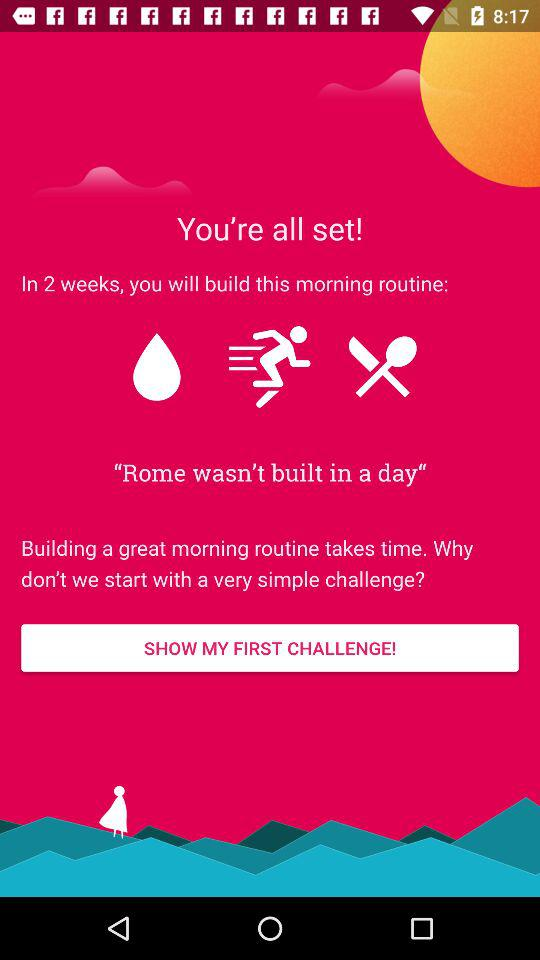How long will it take to establish a morning routine? It will take 2 weeks to establish a morning routine. 